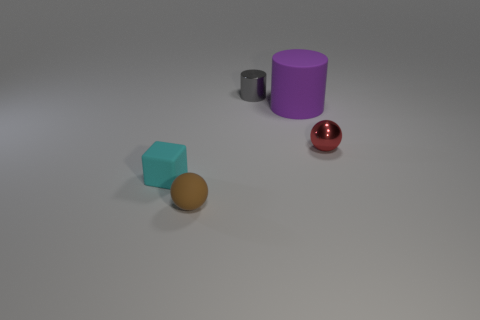Subtract all purple blocks. Subtract all green cylinders. How many blocks are left? 1 Add 4 tiny cyan blocks. How many objects exist? 9 Subtract all cylinders. How many objects are left? 3 Subtract all big yellow metallic spheres. Subtract all large objects. How many objects are left? 4 Add 1 brown rubber things. How many brown rubber things are left? 2 Add 2 small yellow spheres. How many small yellow spheres exist? 2 Subtract 0 purple cubes. How many objects are left? 5 